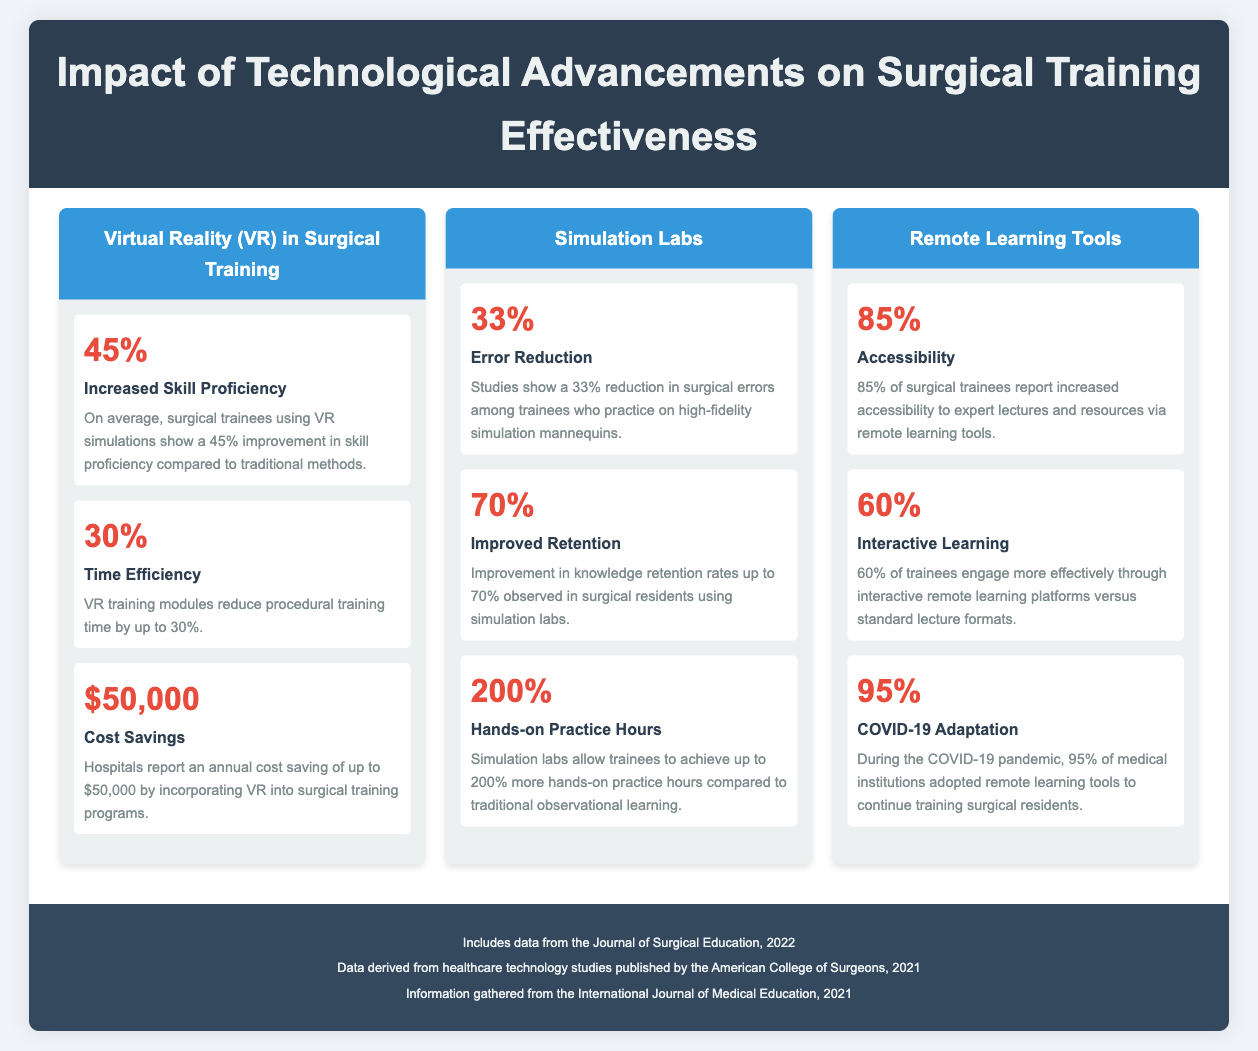What is the percentage increase in skill proficiency when using VR simulations? The infographic states that surgical trainees using VR simulations show a 45% improvement in skill proficiency compared to traditional methods.
Answer: 45% What is the reported annual cost saving by incorporating VR into surgical training programs? According to the document, hospitals report an annual cost saving of up to $50,000 by incorporating VR into surgical training programs.
Answer: $50,000 What percentage reduction in surgical errors is observed with high-fidelity simulation mannequins? The document mentions a 33% reduction in surgical errors among trainees who practice on high-fidelity simulation mannequins.
Answer: 33% How much improvement in knowledge retention rates do simulation labs provide? The infographic indicates that an improvement in knowledge retention rates up to 70% is observed in surgical residents using simulation labs.
Answer: 70% What percentage of surgical trainees report increased accessibility to expert lectures via remote learning tools? The document states that 85% of surgical trainees report increased accessibility to expert lectures and resources via remote learning tools.
Answer: 85% What was the percentage of medical institutions that adapted remote learning tools during the COVID-19 pandemic? The infographic highlights that 95% of medical institutions adopted remote learning tools to continue training surgical residents during the COVID-19 pandemic.
Answer: 95% How much more hands-on practice hours do simulation labs facilitate compared to traditional observational learning? According to the document, simulation labs allow trainees to achieve up to 200% more hands-on practice hours compared to traditional observational learning.
Answer: 200% What is the percentage of trainees that engage more effectively through interactive remote learning platforms? The document states that 60% of trainees engage more effectively through interactive remote learning platforms versus standard lecture formats.
Answer: 60% What is the color of the section header for Simulation Labs? The infographic uses a blue background (3498db) for the section header dedicated to Simulation Labs.
Answer: Blue 